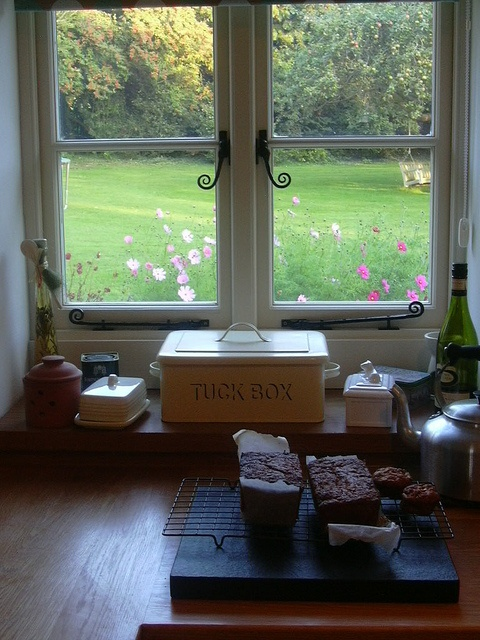Describe the objects in this image and their specific colors. I can see cake in gray and black tones, bottle in gray, black, and darkgreen tones, cake in gray and black tones, cake in gray, black, and maroon tones, and cake in gray, black, and maroon tones in this image. 